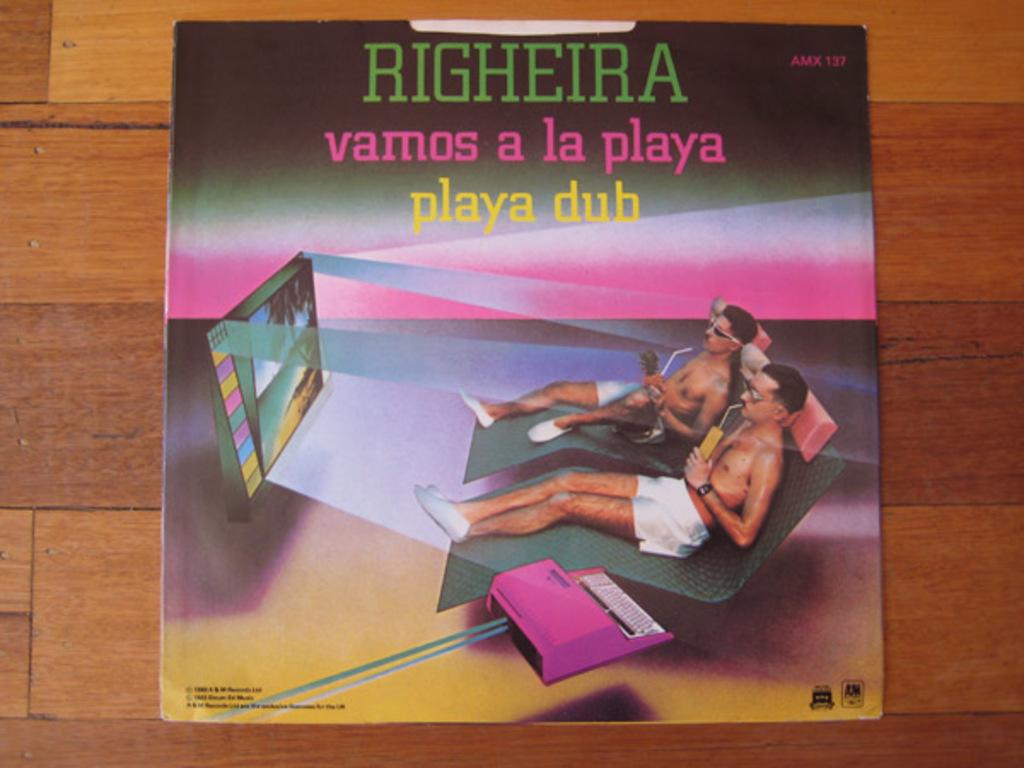What three numbers are shown on the top right of this disc?
Make the answer very short. 137. What is the artists name?
Your response must be concise. Righeira. 